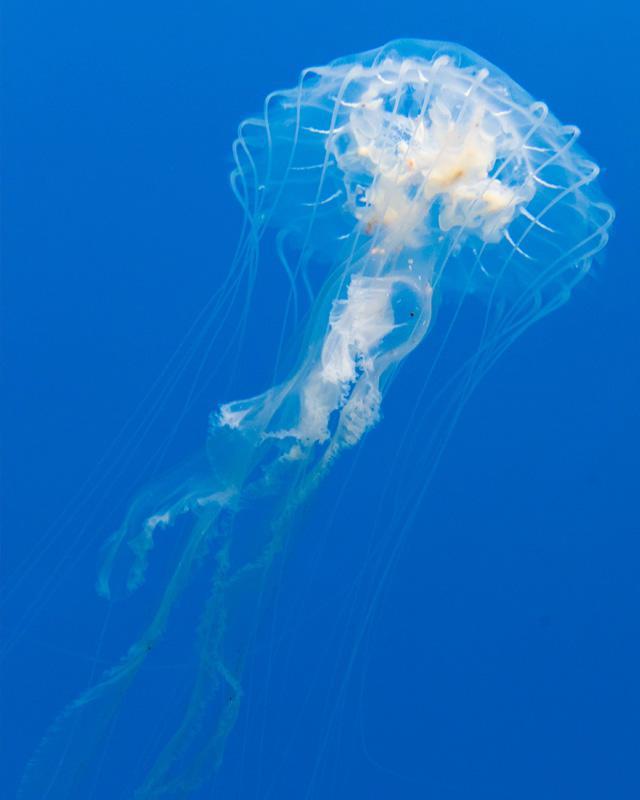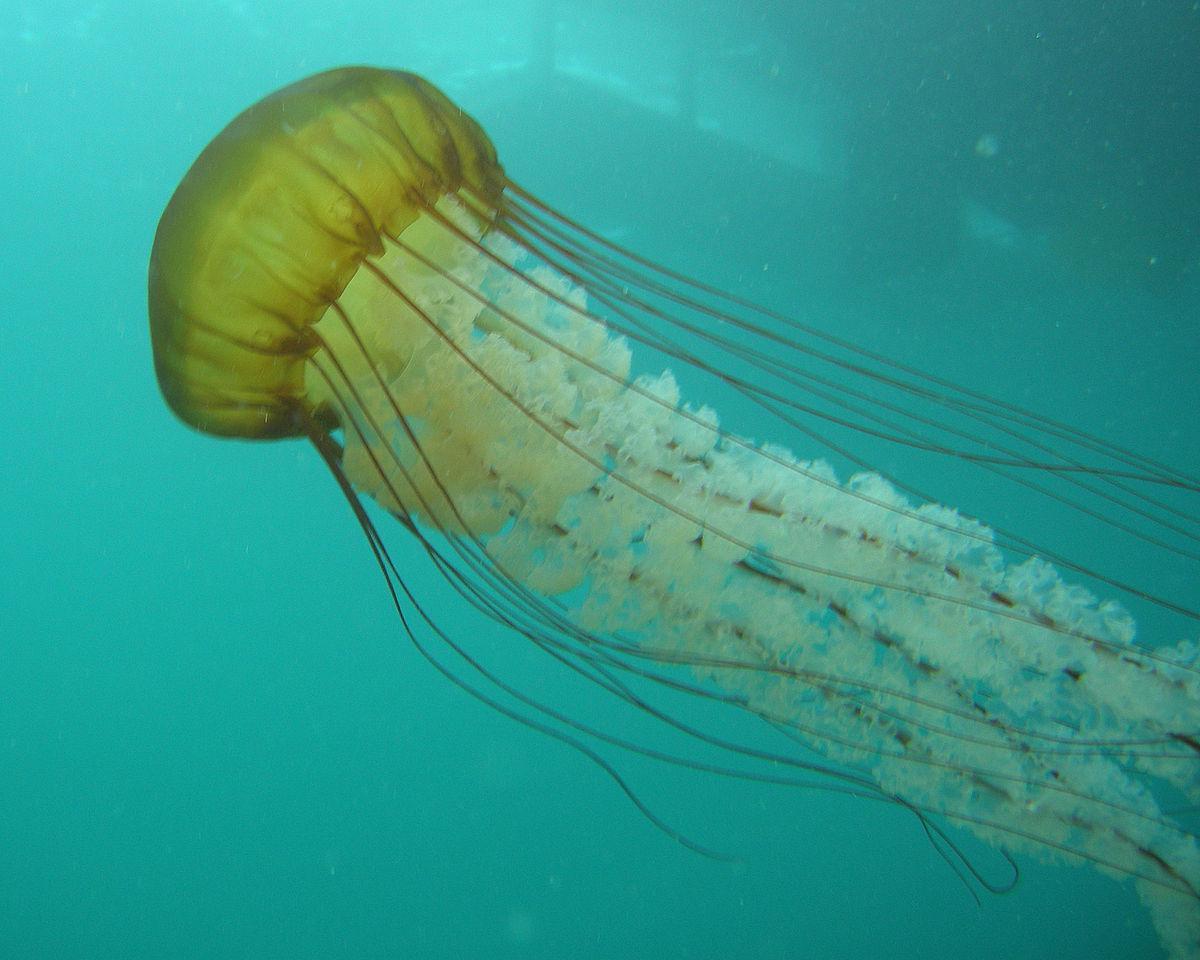The first image is the image on the left, the second image is the image on the right. For the images displayed, is the sentence "Both images contain a single jellyfish." factually correct? Answer yes or no. Yes. 